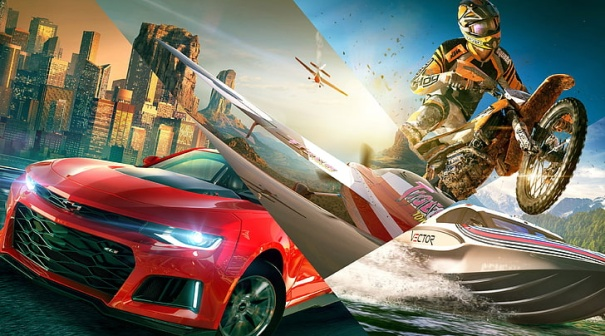What story could be behind this exciting scene? This thrilling scene could be set in a world where an annual mega-race is taking place, a race that spans land, water, and air. The red sports car, driven by a renowned racer, speeds through the city streets, hitting incredible speeds. Meanwhile, a daredevil motorcyclist attempts gravity-defying stunts to catch up, seeking to outshine competitors with his display of skills. The speedboat, operated by a champion sailor, navigates the waters, showcasing agility and finesse. Beyond the race, high above, a pilot in a small aircraft provides an exciting aerial view for spectators. This annual event, known as the 'Tri-Terrain Thrill Race,' is a spectacle that brings the city to a standstill, as people from all realms of transport compete to claim the ultimate title of greatest racer across land, water, and air. 